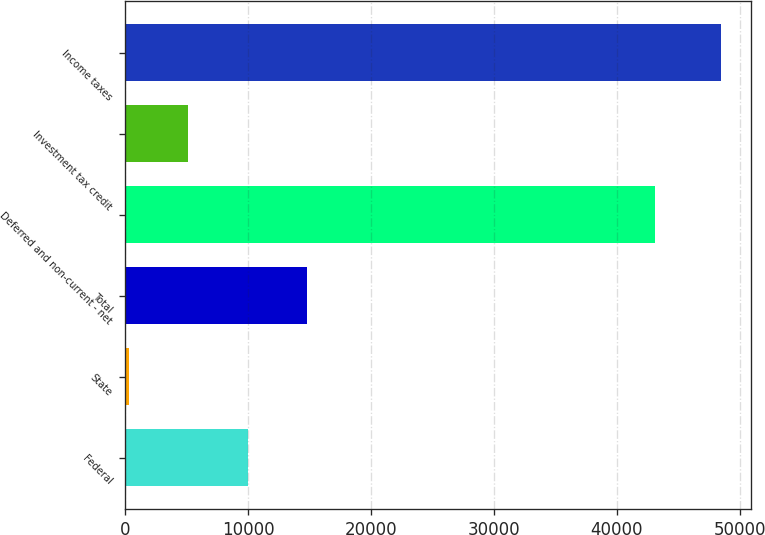<chart> <loc_0><loc_0><loc_500><loc_500><bar_chart><fcel>Federal<fcel>State<fcel>Total<fcel>Deferred and non-current - net<fcel>Investment tax credit<fcel>Income taxes<nl><fcel>9944.2<fcel>310<fcel>14761.3<fcel>43102<fcel>5127.1<fcel>48481<nl></chart> 